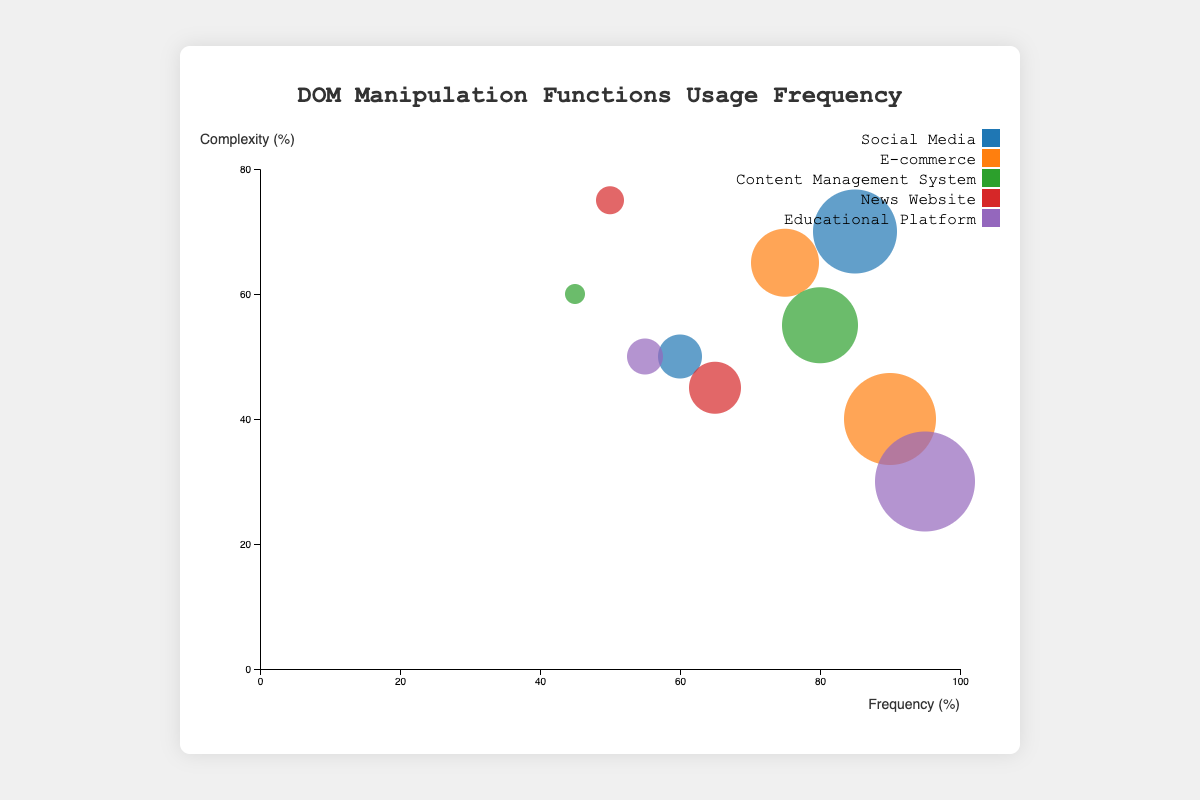How many different types of web applications are represented in the figure? Count the distinct application types visible in the legend. The application types are Social Media, E-commerce, Content Management System, News Website, and Educational Platform.
Answer: 5 Which DOM manipulation function has the highest frequency among all application types? Identify the bubble with the highest frequency on the x-axis. The highest value on the x-axis is 95% for the 'innerHTML' operation in Educational Platform.
Answer: innerHTML What is the relationship between the complexity and frequency of the 'replaceChild' operation in News Websites? Look for the 'replaceChild' operation under News Websites. The x-coordinate (frequency) is 50%, and the y-coordinate (complexity) is 75%.
Answer: Frequency: 50%, Complexity: 75% For Social Media applications, which DOM manipulation operation has a higher complexity: 'getElementById' or 'appendChild'? Compare the y-coordinates (complexity) of the 'getElementById' and 'appendChild' operations under Social Media. 'getElementById' is at 70% and 'appendChild' at 50%.
Answer: getElementById Calculate the average complexity of DOM operations for E-commerce applications. Find the complexity values for E-commerce operations (getElementsByClassName: 65%, createElement: 40%) and calculate the average. The sum is 65 + 40 = 105, and the average is 105/2.
Answer: 52.5% Which application type has the largest bubble, and what DOM operation does it represent? Identify the largest bubble by comparing the sizes, which correspond to frequency values. The largest bubble size corresponds to the highest frequency, which is 'innerHTML' at 95% for Educational Platform.
Answer: Educational Platform, innerHTML Compare the frequency of 'querySelector' in Content Management System with 'getElementsByTagName' in News Website. Which is higher? Find the frequency values for 'querySelector' in Content Management System (80%) and 'getElementsByTagName' in News Website (65%). The higher frequency is 80%.
Answer: querySelector What is the total frequency of all operations under Content Management Systems? Sum the frequency values of operations under Content Management System (querySelector: 80%, removeChild: 45%). The total is 80 + 45 = 125.
Answer: 125% Which DOM manipulation function has the highest complexity among all operations? Identify the bubble with the highest y-coordinate (complexity). The highest value is 75%, corresponding to 'replaceChild' in News Website.
Answer: replaceChild Is the complexity of 'createElement' in E-commerce applications higher than the complexity of 'setAttribute' in Educational Platforms? Compare the y-coordinates of 'createElement' (40%) in E-commerce and 'setAttribute' (50%) in Educational Platforms. The complexity of 'createElement' is lower.
Answer: No 